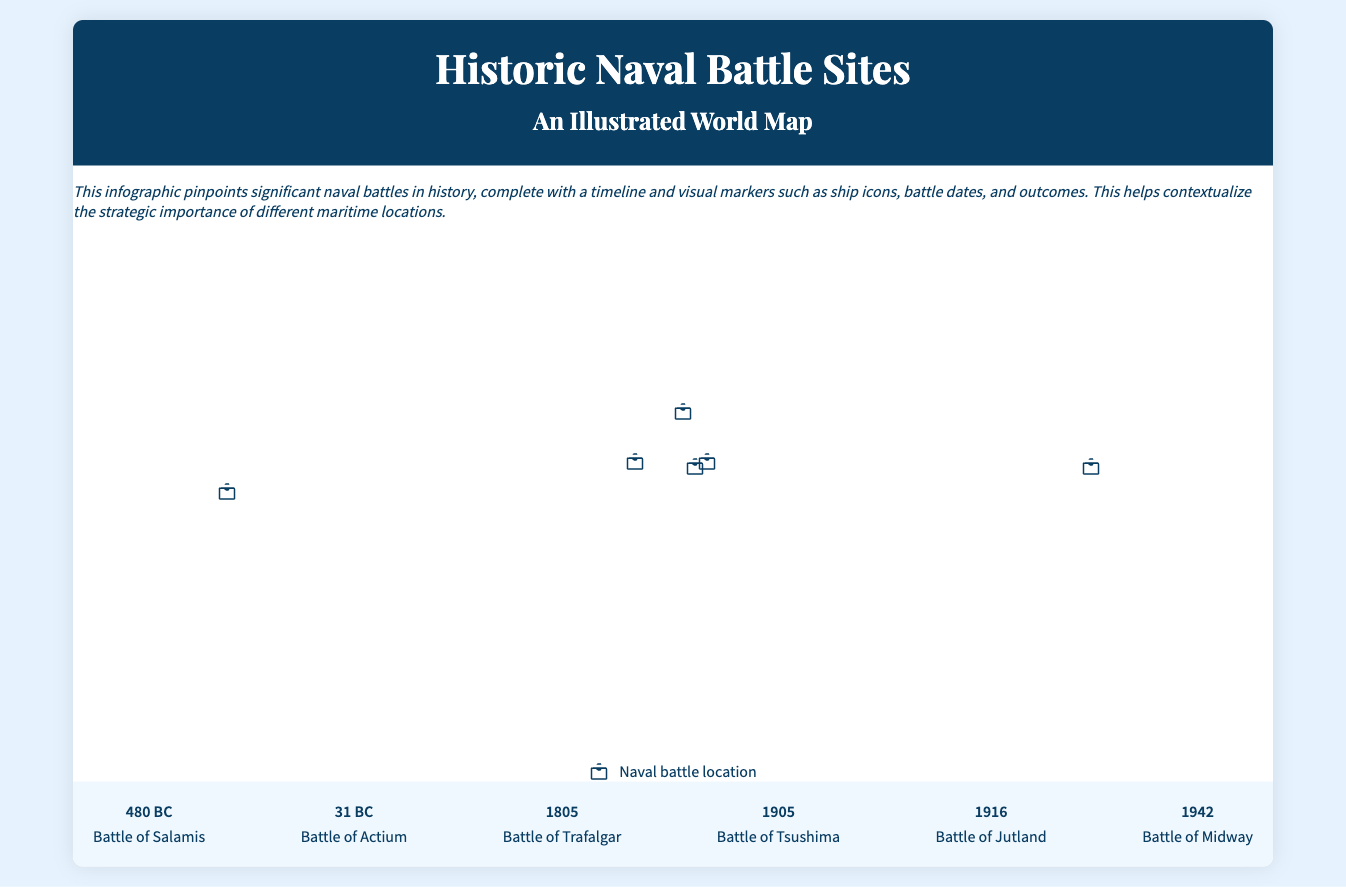What year did the Battle of Salamis occur? The Battle of Salamis is listed in the timeline with its date mentioned clearly.
Answer: 480 BC What was the outcome of the Battle of Trafalgar? The outcome of the Battle of Trafalgar is noted in the battle information as a "Decisive British victory."
Answer: Decisive British victory Which battle marked a turning point in the Pacific Theater during World War II? The infographic states that the Battle of Midway significantly weakened the Japanese naval strength.
Answer: Battle of Midway What significant event occurred in 31 BC? The infographic highlights the Battle of Actium occurring in that year, which is also mentioned in the timeline.
Answer: Battle of Actium Which naval battle is associated with Admiral Horatio Nelson? The outcome of the Battle of Trafalgar is connected with Admiral Horatio Nelson in the document details.
Answer: Battle of Trafalgar What significant change did the Battle of Tsushima represent? The document states that it was the first time an Asian power defeated a European power in modern warfare.
Answer: Change in power balance How are the naval battles represented on the map? The map uses visual markers in the form of ship icons to indicate different battle sites.
Answer: Ship icons What is the duration of the Battle of Jutland? The timeframe of the battle is noted in the timeline, which provides the exact dates.
Answer: May 31 – June 1, 1916 